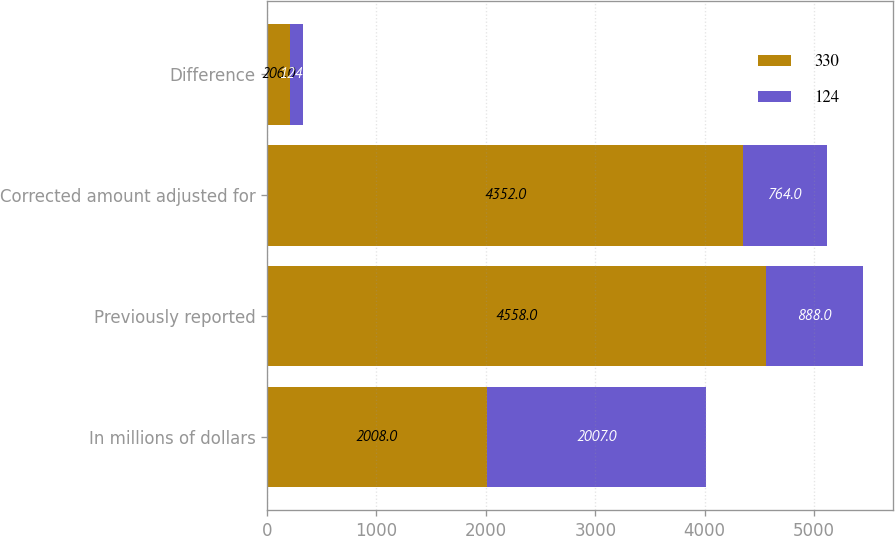Convert chart to OTSL. <chart><loc_0><loc_0><loc_500><loc_500><stacked_bar_chart><ecel><fcel>In millions of dollars<fcel>Previously reported<fcel>Corrected amount adjusted for<fcel>Difference<nl><fcel>330<fcel>2008<fcel>4558<fcel>4352<fcel>206<nl><fcel>124<fcel>2007<fcel>888<fcel>764<fcel>124<nl></chart> 